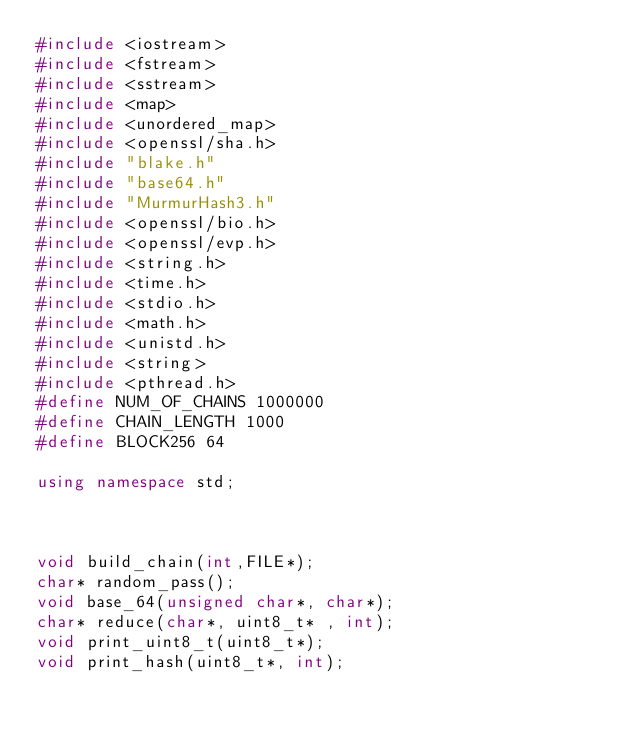<code> <loc_0><loc_0><loc_500><loc_500><_C++_>#include <iostream>
#include <fstream>
#include <sstream>
#include <map>
#include <unordered_map>
#include <openssl/sha.h>
#include "blake.h"
#include "base64.h"
#include "MurmurHash3.h"
#include <openssl/bio.h>
#include <openssl/evp.h>
#include <string.h>
#include <time.h>
#include <stdio.h>
#include <math.h>
#include <unistd.h>
#include <string>
#include <pthread.h>
#define NUM_OF_CHAINS 1000000
#define CHAIN_LENGTH 1000
#define BLOCK256 64

using namespace std;



void build_chain(int,FILE*);
char* random_pass();
void base_64(unsigned char*, char*);
char* reduce(char*, uint8_t* , int);
void print_uint8_t(uint8_t*);
void print_hash(uint8_t*, int);</code> 